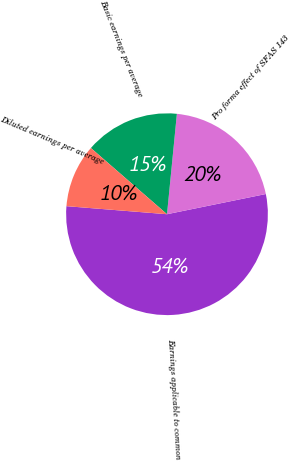Convert chart. <chart><loc_0><loc_0><loc_500><loc_500><pie_chart><fcel>Earnings applicable to common<fcel>Pro forma effect of SFAS 143<fcel>Basic earnings per average<fcel>Diluted earnings per average<nl><fcel>54.48%<fcel>20.23%<fcel>15.17%<fcel>10.12%<nl></chart> 